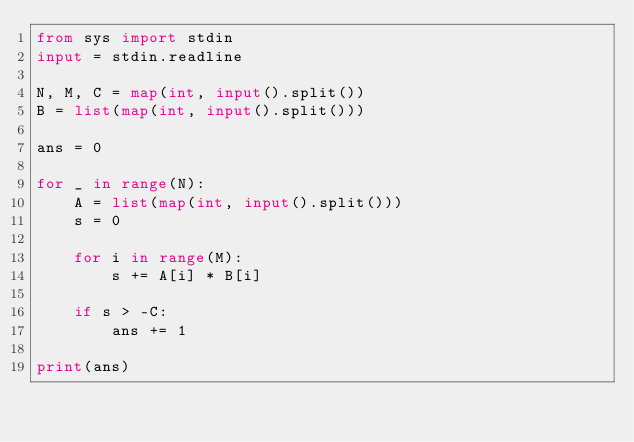Convert code to text. <code><loc_0><loc_0><loc_500><loc_500><_Python_>from sys import stdin
input = stdin.readline

N, M, C = map(int, input().split())
B = list(map(int, input().split()))

ans = 0

for _ in range(N):
    A = list(map(int, input().split()))
    s = 0

    for i in range(M):
        s += A[i] * B[i]

    if s > -C:
        ans += 1

print(ans)
</code> 